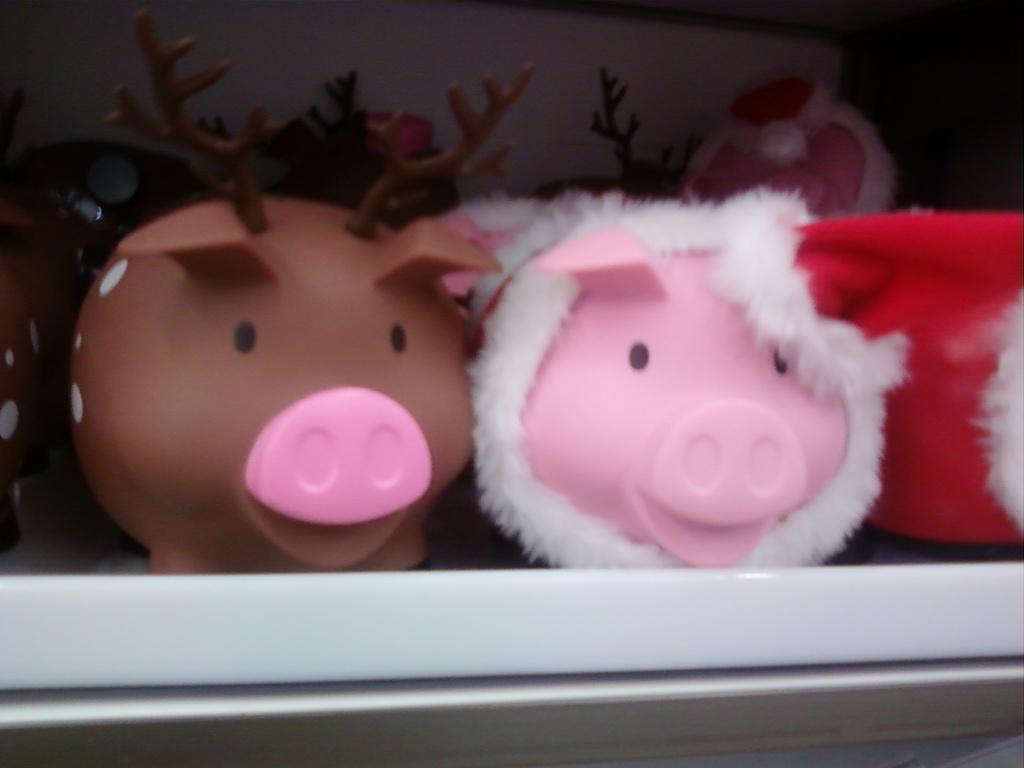What objects are present in the image? There are toys in the image. Where are the toys located? The toys are on a rack. What type of leather material can be seen on the toys in the image? There is no leather material present on the toys in the image. 